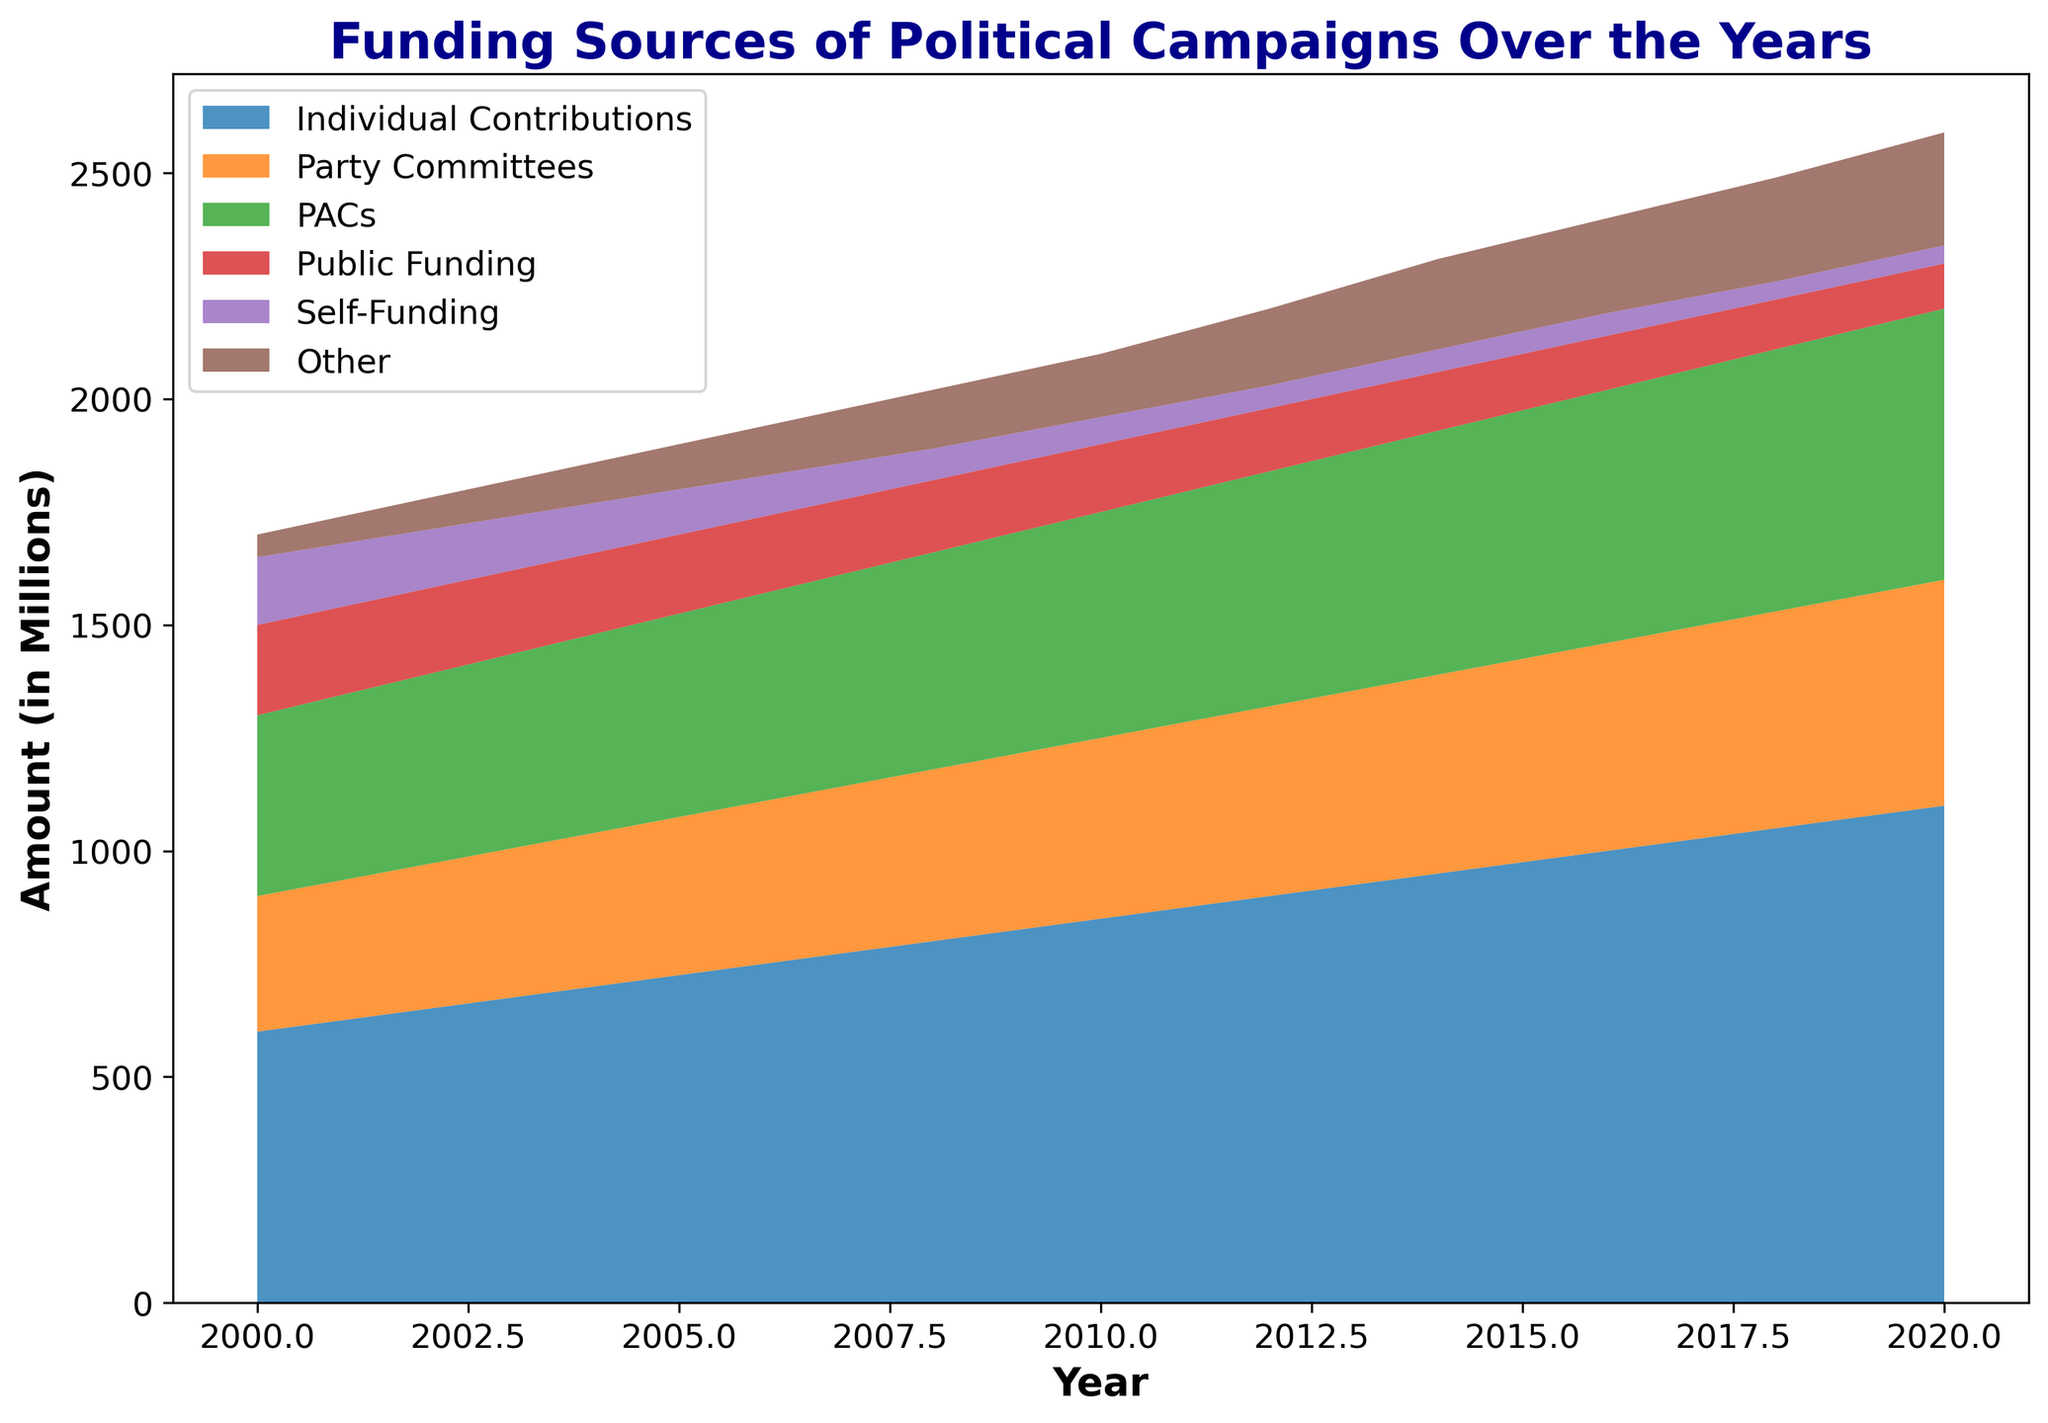What is the trend of Individual Contributions over the years? The 'Individual Contributions' section in the area chart consistently increases from 600 million in 2000 to 1100 million in 2020, indicating a steady upward trend.
Answer: Increasing Which funding source has the smallest values in 2020, and what is it? In 2020, 'Self-Funding' and 'Public Funding' have the smallest values with 'Self-Funding' at 40 million and 'Public Funding' at 100 million. Among them, 'Self-Funding' is the smallest.
Answer: Self-Funding, 40 million How does the amount from Party Committees compare between 2000 and 2020? Party Committees' funding increases from 300 million in 2000 to 500 million in 2020, showing a clear increase of 200 million over the two decades.
Answer: Increased by 200 million What is the total funding from PACs and Public Funding in 2004? The amount from PACs in 2004 is 440 million and from Public Funding is 180 million. Summing these values, 440 + 180 = 620 million.
Answer: 620 million Which funding category shows the highest increase from 2000 to 2020? The 'Individual Contributions' category shows the highest increase from 600 million in 2000 to 1100 million in 2020, an increase of 500 million.
Answer: Individual Contributions Do Individual Contributions contribute more than Party Committees and PACs combined in 2020? In 2020, Individual Contributions are 1100 million. Party Committees are 500 million and PACs are 600 million, summing up to 1100 million. They are exactly equal.
Answer: Equal What is the average annual increase in Self-Funding from 2008 to 2020? In 2008, Self-Funding is 70 million and in 2020 it is 40 million. From 2008 to 2020 (12 years), the overall decrease is 70 - 40 = 30 million. The average annual decrease is 30/12 ≈ 2.50 million.
Answer: Decreased by 2.50 million per year Are total contributions from other sources higher in 2010 or 2020? Total contributions from other sources in 2010 is 140 million. In 2020, it is 250 million. Thus, contributions from other sources are higher in 2020.
Answer: 2020 By how much does Public Funding decrease from 2000 to 2020? Public Funding decreases from 200 million in 2000 to 100 million in 2020, resulting in a decrease of 200 - 100 = 100 million.
Answer: 100 million Which category has the most variation over the years? 'Individual Contributions' show the most variation, increasing from 600 million in 2000 to 1100 million in 2020, a change of 500 million.
Answer: Individual Contributions 